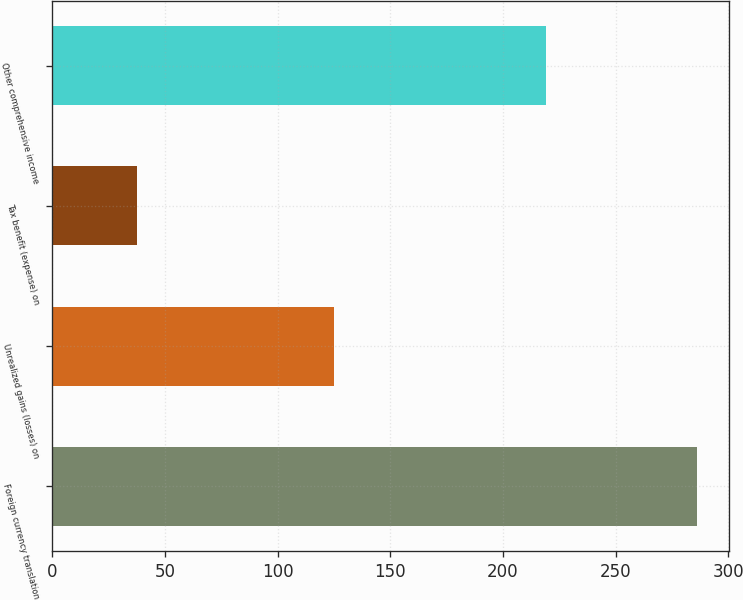<chart> <loc_0><loc_0><loc_500><loc_500><bar_chart><fcel>Foreign currency translation<fcel>Unrealized gains (losses) on<fcel>Tax benefit (expense) on<fcel>Other comprehensive income<nl><fcel>286<fcel>125<fcel>37.6<fcel>219<nl></chart> 